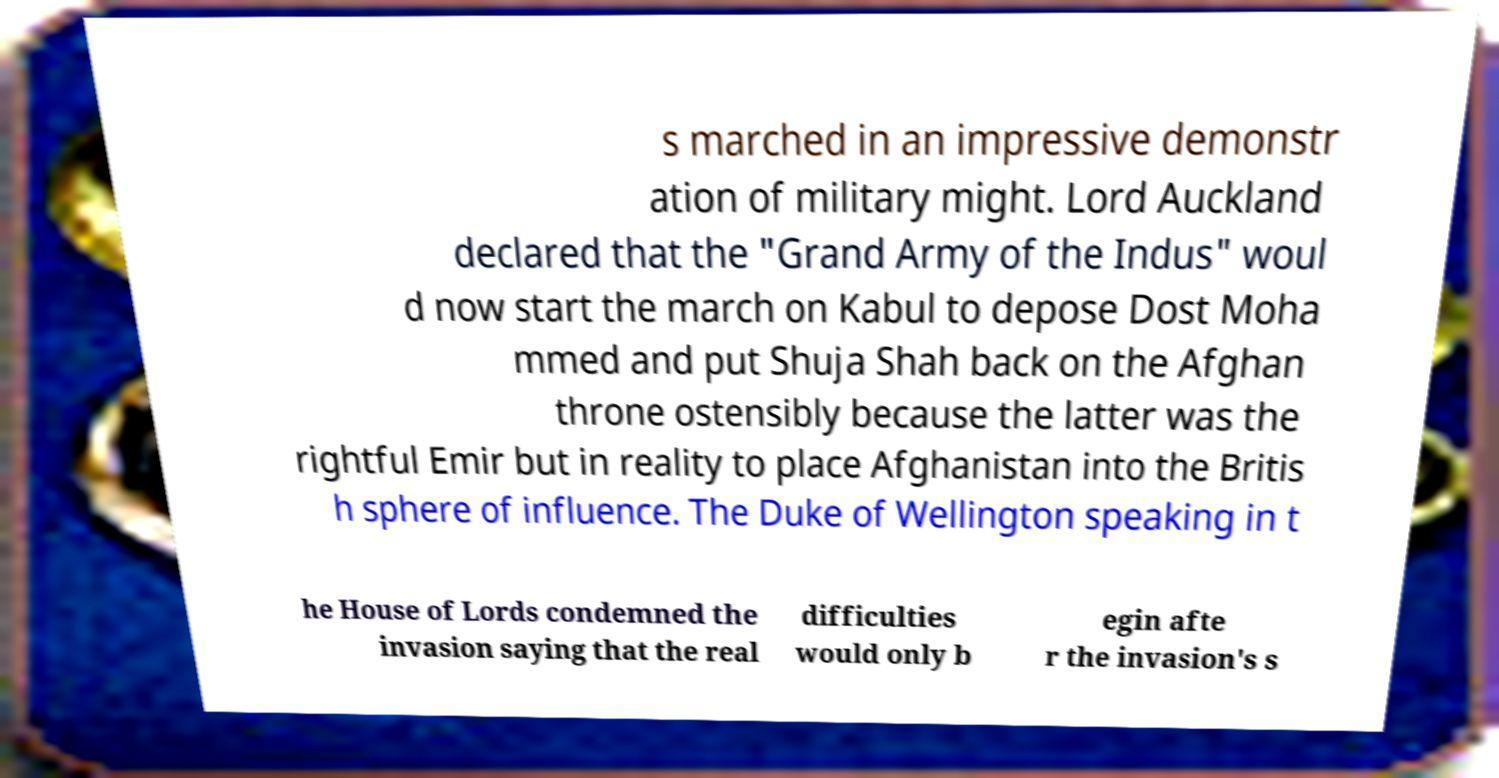There's text embedded in this image that I need extracted. Can you transcribe it verbatim? s marched in an impressive demonstr ation of military might. Lord Auckland declared that the "Grand Army of the Indus" woul d now start the march on Kabul to depose Dost Moha mmed and put Shuja Shah back on the Afghan throne ostensibly because the latter was the rightful Emir but in reality to place Afghanistan into the Britis h sphere of influence. The Duke of Wellington speaking in t he House of Lords condemned the invasion saying that the real difficulties would only b egin afte r the invasion's s 